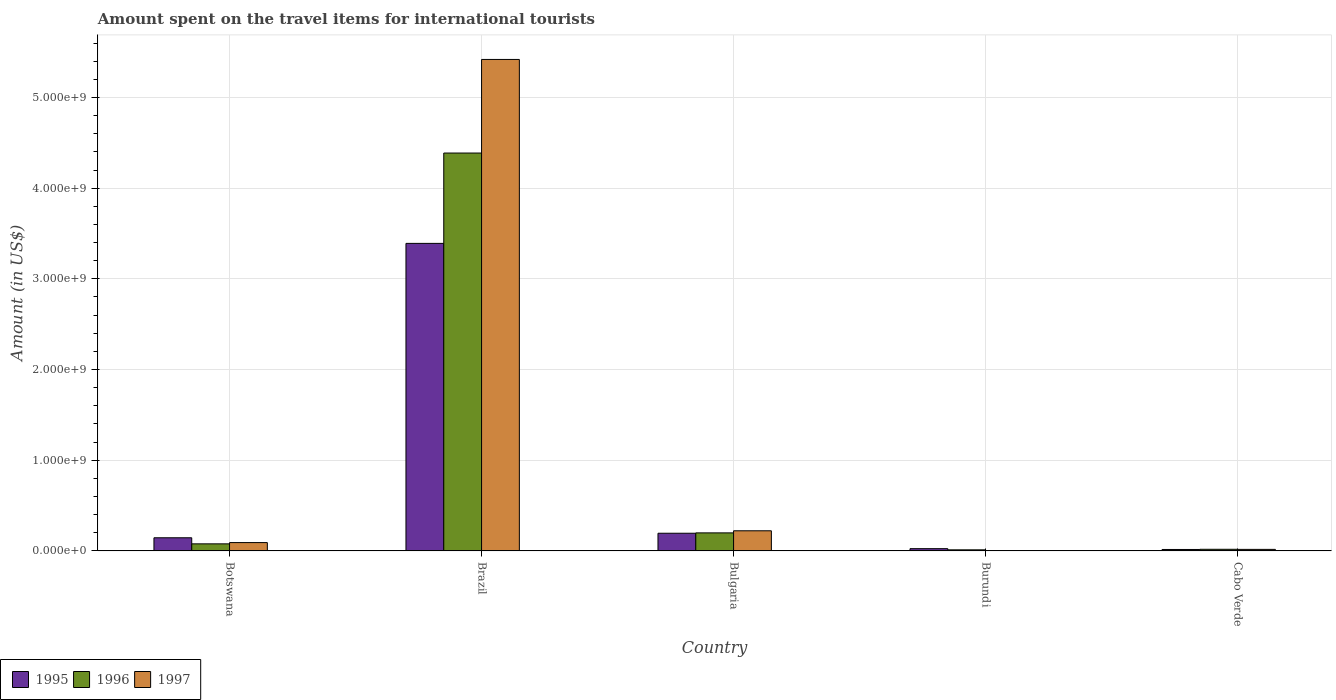How many groups of bars are there?
Your answer should be compact. 5. Are the number of bars per tick equal to the number of legend labels?
Keep it short and to the point. Yes. Are the number of bars on each tick of the X-axis equal?
Keep it short and to the point. Yes. How many bars are there on the 5th tick from the right?
Offer a terse response. 3. What is the label of the 5th group of bars from the left?
Ensure brevity in your answer.  Cabo Verde. In how many cases, is the number of bars for a given country not equal to the number of legend labels?
Provide a short and direct response. 0. What is the amount spent on the travel items for international tourists in 1997 in Burundi?
Offer a terse response. 4.00e+06. Across all countries, what is the maximum amount spent on the travel items for international tourists in 1996?
Offer a very short reply. 4.39e+09. Across all countries, what is the minimum amount spent on the travel items for international tourists in 1995?
Keep it short and to the point. 1.60e+07. In which country was the amount spent on the travel items for international tourists in 1997 maximum?
Keep it short and to the point. Brazil. In which country was the amount spent on the travel items for international tourists in 1995 minimum?
Give a very brief answer. Cabo Verde. What is the total amount spent on the travel items for international tourists in 1996 in the graph?
Your answer should be very brief. 4.69e+09. What is the difference between the amount spent on the travel items for international tourists in 1996 in Brazil and that in Cabo Verde?
Your response must be concise. 4.37e+09. What is the difference between the amount spent on the travel items for international tourists in 1997 in Cabo Verde and the amount spent on the travel items for international tourists in 1996 in Brazil?
Offer a very short reply. -4.37e+09. What is the average amount spent on the travel items for international tourists in 1997 per country?
Your answer should be very brief. 1.15e+09. What is the difference between the amount spent on the travel items for international tourists of/in 1997 and amount spent on the travel items for international tourists of/in 1995 in Brazil?
Your answer should be compact. 2.03e+09. What is the ratio of the amount spent on the travel items for international tourists in 1995 in Brazil to that in Cabo Verde?
Your answer should be compact. 211.94. Is the difference between the amount spent on the travel items for international tourists in 1997 in Burundi and Cabo Verde greater than the difference between the amount spent on the travel items for international tourists in 1995 in Burundi and Cabo Verde?
Keep it short and to the point. No. What is the difference between the highest and the second highest amount spent on the travel items for international tourists in 1997?
Your response must be concise. 5.33e+09. What is the difference between the highest and the lowest amount spent on the travel items for international tourists in 1996?
Give a very brief answer. 4.38e+09. In how many countries, is the amount spent on the travel items for international tourists in 1995 greater than the average amount spent on the travel items for international tourists in 1995 taken over all countries?
Keep it short and to the point. 1. What does the 1st bar from the left in Brazil represents?
Provide a succinct answer. 1995. Is it the case that in every country, the sum of the amount spent on the travel items for international tourists in 1996 and amount spent on the travel items for international tourists in 1995 is greater than the amount spent on the travel items for international tourists in 1997?
Keep it short and to the point. Yes. How many bars are there?
Provide a succinct answer. 15. How many countries are there in the graph?
Make the answer very short. 5. Are the values on the major ticks of Y-axis written in scientific E-notation?
Your response must be concise. Yes. Where does the legend appear in the graph?
Provide a succinct answer. Bottom left. How are the legend labels stacked?
Make the answer very short. Horizontal. What is the title of the graph?
Make the answer very short. Amount spent on the travel items for international tourists. What is the label or title of the Y-axis?
Provide a succinct answer. Amount (in US$). What is the Amount (in US$) of 1995 in Botswana?
Make the answer very short. 1.45e+08. What is the Amount (in US$) in 1996 in Botswana?
Your answer should be very brief. 7.80e+07. What is the Amount (in US$) of 1997 in Botswana?
Make the answer very short. 9.20e+07. What is the Amount (in US$) in 1995 in Brazil?
Make the answer very short. 3.39e+09. What is the Amount (in US$) in 1996 in Brazil?
Make the answer very short. 4.39e+09. What is the Amount (in US$) in 1997 in Brazil?
Ensure brevity in your answer.  5.42e+09. What is the Amount (in US$) of 1995 in Bulgaria?
Your answer should be compact. 1.95e+08. What is the Amount (in US$) of 1996 in Bulgaria?
Give a very brief answer. 1.99e+08. What is the Amount (in US$) in 1997 in Bulgaria?
Ensure brevity in your answer.  2.22e+08. What is the Amount (in US$) of 1995 in Burundi?
Your response must be concise. 2.50e+07. What is the Amount (in US$) in 1995 in Cabo Verde?
Ensure brevity in your answer.  1.60e+07. What is the Amount (in US$) in 1996 in Cabo Verde?
Keep it short and to the point. 1.80e+07. What is the Amount (in US$) in 1997 in Cabo Verde?
Keep it short and to the point. 1.70e+07. Across all countries, what is the maximum Amount (in US$) of 1995?
Your answer should be very brief. 3.39e+09. Across all countries, what is the maximum Amount (in US$) of 1996?
Make the answer very short. 4.39e+09. Across all countries, what is the maximum Amount (in US$) of 1997?
Provide a succinct answer. 5.42e+09. Across all countries, what is the minimum Amount (in US$) in 1995?
Offer a very short reply. 1.60e+07. Across all countries, what is the minimum Amount (in US$) of 1997?
Keep it short and to the point. 4.00e+06. What is the total Amount (in US$) of 1995 in the graph?
Your response must be concise. 3.77e+09. What is the total Amount (in US$) of 1996 in the graph?
Ensure brevity in your answer.  4.69e+09. What is the total Amount (in US$) in 1997 in the graph?
Make the answer very short. 5.75e+09. What is the difference between the Amount (in US$) in 1995 in Botswana and that in Brazil?
Your answer should be compact. -3.25e+09. What is the difference between the Amount (in US$) of 1996 in Botswana and that in Brazil?
Ensure brevity in your answer.  -4.31e+09. What is the difference between the Amount (in US$) in 1997 in Botswana and that in Brazil?
Give a very brief answer. -5.33e+09. What is the difference between the Amount (in US$) of 1995 in Botswana and that in Bulgaria?
Your response must be concise. -5.00e+07. What is the difference between the Amount (in US$) of 1996 in Botswana and that in Bulgaria?
Provide a succinct answer. -1.21e+08. What is the difference between the Amount (in US$) of 1997 in Botswana and that in Bulgaria?
Your response must be concise. -1.30e+08. What is the difference between the Amount (in US$) in 1995 in Botswana and that in Burundi?
Give a very brief answer. 1.20e+08. What is the difference between the Amount (in US$) in 1996 in Botswana and that in Burundi?
Ensure brevity in your answer.  6.60e+07. What is the difference between the Amount (in US$) of 1997 in Botswana and that in Burundi?
Ensure brevity in your answer.  8.80e+07. What is the difference between the Amount (in US$) in 1995 in Botswana and that in Cabo Verde?
Give a very brief answer. 1.29e+08. What is the difference between the Amount (in US$) in 1996 in Botswana and that in Cabo Verde?
Your answer should be very brief. 6.00e+07. What is the difference between the Amount (in US$) in 1997 in Botswana and that in Cabo Verde?
Make the answer very short. 7.50e+07. What is the difference between the Amount (in US$) of 1995 in Brazil and that in Bulgaria?
Your response must be concise. 3.20e+09. What is the difference between the Amount (in US$) of 1996 in Brazil and that in Bulgaria?
Offer a terse response. 4.19e+09. What is the difference between the Amount (in US$) in 1997 in Brazil and that in Bulgaria?
Your answer should be compact. 5.20e+09. What is the difference between the Amount (in US$) of 1995 in Brazil and that in Burundi?
Make the answer very short. 3.37e+09. What is the difference between the Amount (in US$) of 1996 in Brazil and that in Burundi?
Your answer should be compact. 4.38e+09. What is the difference between the Amount (in US$) of 1997 in Brazil and that in Burundi?
Provide a short and direct response. 5.42e+09. What is the difference between the Amount (in US$) in 1995 in Brazil and that in Cabo Verde?
Ensure brevity in your answer.  3.38e+09. What is the difference between the Amount (in US$) of 1996 in Brazil and that in Cabo Verde?
Provide a short and direct response. 4.37e+09. What is the difference between the Amount (in US$) in 1997 in Brazil and that in Cabo Verde?
Offer a very short reply. 5.40e+09. What is the difference between the Amount (in US$) of 1995 in Bulgaria and that in Burundi?
Offer a very short reply. 1.70e+08. What is the difference between the Amount (in US$) of 1996 in Bulgaria and that in Burundi?
Make the answer very short. 1.87e+08. What is the difference between the Amount (in US$) of 1997 in Bulgaria and that in Burundi?
Your answer should be very brief. 2.18e+08. What is the difference between the Amount (in US$) in 1995 in Bulgaria and that in Cabo Verde?
Your response must be concise. 1.79e+08. What is the difference between the Amount (in US$) in 1996 in Bulgaria and that in Cabo Verde?
Make the answer very short. 1.81e+08. What is the difference between the Amount (in US$) in 1997 in Bulgaria and that in Cabo Verde?
Your answer should be very brief. 2.05e+08. What is the difference between the Amount (in US$) in 1995 in Burundi and that in Cabo Verde?
Offer a very short reply. 9.00e+06. What is the difference between the Amount (in US$) of 1996 in Burundi and that in Cabo Verde?
Offer a terse response. -6.00e+06. What is the difference between the Amount (in US$) of 1997 in Burundi and that in Cabo Verde?
Offer a very short reply. -1.30e+07. What is the difference between the Amount (in US$) of 1995 in Botswana and the Amount (in US$) of 1996 in Brazil?
Offer a very short reply. -4.24e+09. What is the difference between the Amount (in US$) of 1995 in Botswana and the Amount (in US$) of 1997 in Brazil?
Keep it short and to the point. -5.27e+09. What is the difference between the Amount (in US$) in 1996 in Botswana and the Amount (in US$) in 1997 in Brazil?
Offer a very short reply. -5.34e+09. What is the difference between the Amount (in US$) in 1995 in Botswana and the Amount (in US$) in 1996 in Bulgaria?
Offer a terse response. -5.40e+07. What is the difference between the Amount (in US$) in 1995 in Botswana and the Amount (in US$) in 1997 in Bulgaria?
Your answer should be very brief. -7.70e+07. What is the difference between the Amount (in US$) of 1996 in Botswana and the Amount (in US$) of 1997 in Bulgaria?
Make the answer very short. -1.44e+08. What is the difference between the Amount (in US$) in 1995 in Botswana and the Amount (in US$) in 1996 in Burundi?
Offer a terse response. 1.33e+08. What is the difference between the Amount (in US$) of 1995 in Botswana and the Amount (in US$) of 1997 in Burundi?
Your answer should be compact. 1.41e+08. What is the difference between the Amount (in US$) of 1996 in Botswana and the Amount (in US$) of 1997 in Burundi?
Give a very brief answer. 7.40e+07. What is the difference between the Amount (in US$) of 1995 in Botswana and the Amount (in US$) of 1996 in Cabo Verde?
Give a very brief answer. 1.27e+08. What is the difference between the Amount (in US$) of 1995 in Botswana and the Amount (in US$) of 1997 in Cabo Verde?
Your answer should be compact. 1.28e+08. What is the difference between the Amount (in US$) of 1996 in Botswana and the Amount (in US$) of 1997 in Cabo Verde?
Offer a very short reply. 6.10e+07. What is the difference between the Amount (in US$) in 1995 in Brazil and the Amount (in US$) in 1996 in Bulgaria?
Your answer should be very brief. 3.19e+09. What is the difference between the Amount (in US$) in 1995 in Brazil and the Amount (in US$) in 1997 in Bulgaria?
Make the answer very short. 3.17e+09. What is the difference between the Amount (in US$) in 1996 in Brazil and the Amount (in US$) in 1997 in Bulgaria?
Your answer should be very brief. 4.16e+09. What is the difference between the Amount (in US$) in 1995 in Brazil and the Amount (in US$) in 1996 in Burundi?
Offer a very short reply. 3.38e+09. What is the difference between the Amount (in US$) in 1995 in Brazil and the Amount (in US$) in 1997 in Burundi?
Ensure brevity in your answer.  3.39e+09. What is the difference between the Amount (in US$) of 1996 in Brazil and the Amount (in US$) of 1997 in Burundi?
Provide a succinct answer. 4.38e+09. What is the difference between the Amount (in US$) in 1995 in Brazil and the Amount (in US$) in 1996 in Cabo Verde?
Your answer should be compact. 3.37e+09. What is the difference between the Amount (in US$) of 1995 in Brazil and the Amount (in US$) of 1997 in Cabo Verde?
Provide a short and direct response. 3.37e+09. What is the difference between the Amount (in US$) of 1996 in Brazil and the Amount (in US$) of 1997 in Cabo Verde?
Make the answer very short. 4.37e+09. What is the difference between the Amount (in US$) of 1995 in Bulgaria and the Amount (in US$) of 1996 in Burundi?
Provide a succinct answer. 1.83e+08. What is the difference between the Amount (in US$) of 1995 in Bulgaria and the Amount (in US$) of 1997 in Burundi?
Your response must be concise. 1.91e+08. What is the difference between the Amount (in US$) in 1996 in Bulgaria and the Amount (in US$) in 1997 in Burundi?
Offer a very short reply. 1.95e+08. What is the difference between the Amount (in US$) in 1995 in Bulgaria and the Amount (in US$) in 1996 in Cabo Verde?
Your answer should be compact. 1.77e+08. What is the difference between the Amount (in US$) in 1995 in Bulgaria and the Amount (in US$) in 1997 in Cabo Verde?
Ensure brevity in your answer.  1.78e+08. What is the difference between the Amount (in US$) in 1996 in Bulgaria and the Amount (in US$) in 1997 in Cabo Verde?
Your answer should be compact. 1.82e+08. What is the difference between the Amount (in US$) of 1996 in Burundi and the Amount (in US$) of 1997 in Cabo Verde?
Provide a succinct answer. -5.00e+06. What is the average Amount (in US$) of 1995 per country?
Provide a short and direct response. 7.54e+08. What is the average Amount (in US$) in 1996 per country?
Give a very brief answer. 9.39e+08. What is the average Amount (in US$) of 1997 per country?
Make the answer very short. 1.15e+09. What is the difference between the Amount (in US$) in 1995 and Amount (in US$) in 1996 in Botswana?
Provide a short and direct response. 6.70e+07. What is the difference between the Amount (in US$) in 1995 and Amount (in US$) in 1997 in Botswana?
Provide a short and direct response. 5.30e+07. What is the difference between the Amount (in US$) in 1996 and Amount (in US$) in 1997 in Botswana?
Your response must be concise. -1.40e+07. What is the difference between the Amount (in US$) in 1995 and Amount (in US$) in 1996 in Brazil?
Provide a succinct answer. -9.96e+08. What is the difference between the Amount (in US$) in 1995 and Amount (in US$) in 1997 in Brazil?
Your response must be concise. -2.03e+09. What is the difference between the Amount (in US$) of 1996 and Amount (in US$) of 1997 in Brazil?
Your answer should be compact. -1.03e+09. What is the difference between the Amount (in US$) of 1995 and Amount (in US$) of 1996 in Bulgaria?
Provide a short and direct response. -4.00e+06. What is the difference between the Amount (in US$) of 1995 and Amount (in US$) of 1997 in Bulgaria?
Your response must be concise. -2.70e+07. What is the difference between the Amount (in US$) in 1996 and Amount (in US$) in 1997 in Bulgaria?
Offer a very short reply. -2.30e+07. What is the difference between the Amount (in US$) of 1995 and Amount (in US$) of 1996 in Burundi?
Your answer should be very brief. 1.30e+07. What is the difference between the Amount (in US$) in 1995 and Amount (in US$) in 1997 in Burundi?
Ensure brevity in your answer.  2.10e+07. What is the difference between the Amount (in US$) of 1996 and Amount (in US$) of 1997 in Cabo Verde?
Your answer should be compact. 1.00e+06. What is the ratio of the Amount (in US$) of 1995 in Botswana to that in Brazil?
Your answer should be compact. 0.04. What is the ratio of the Amount (in US$) of 1996 in Botswana to that in Brazil?
Keep it short and to the point. 0.02. What is the ratio of the Amount (in US$) of 1997 in Botswana to that in Brazil?
Your response must be concise. 0.02. What is the ratio of the Amount (in US$) of 1995 in Botswana to that in Bulgaria?
Your answer should be compact. 0.74. What is the ratio of the Amount (in US$) in 1996 in Botswana to that in Bulgaria?
Make the answer very short. 0.39. What is the ratio of the Amount (in US$) in 1997 in Botswana to that in Bulgaria?
Provide a short and direct response. 0.41. What is the ratio of the Amount (in US$) of 1996 in Botswana to that in Burundi?
Offer a terse response. 6.5. What is the ratio of the Amount (in US$) of 1997 in Botswana to that in Burundi?
Provide a short and direct response. 23. What is the ratio of the Amount (in US$) in 1995 in Botswana to that in Cabo Verde?
Provide a succinct answer. 9.06. What is the ratio of the Amount (in US$) in 1996 in Botswana to that in Cabo Verde?
Your answer should be very brief. 4.33. What is the ratio of the Amount (in US$) in 1997 in Botswana to that in Cabo Verde?
Give a very brief answer. 5.41. What is the ratio of the Amount (in US$) of 1995 in Brazil to that in Bulgaria?
Your answer should be compact. 17.39. What is the ratio of the Amount (in US$) in 1996 in Brazil to that in Bulgaria?
Provide a succinct answer. 22.05. What is the ratio of the Amount (in US$) of 1997 in Brazil to that in Bulgaria?
Provide a succinct answer. 24.41. What is the ratio of the Amount (in US$) of 1995 in Brazil to that in Burundi?
Provide a succinct answer. 135.64. What is the ratio of the Amount (in US$) in 1996 in Brazil to that in Burundi?
Ensure brevity in your answer.  365.58. What is the ratio of the Amount (in US$) of 1997 in Brazil to that in Burundi?
Your response must be concise. 1354.75. What is the ratio of the Amount (in US$) of 1995 in Brazil to that in Cabo Verde?
Your answer should be compact. 211.94. What is the ratio of the Amount (in US$) of 1996 in Brazil to that in Cabo Verde?
Offer a terse response. 243.72. What is the ratio of the Amount (in US$) in 1997 in Brazil to that in Cabo Verde?
Your answer should be compact. 318.76. What is the ratio of the Amount (in US$) of 1996 in Bulgaria to that in Burundi?
Provide a short and direct response. 16.58. What is the ratio of the Amount (in US$) in 1997 in Bulgaria to that in Burundi?
Your response must be concise. 55.5. What is the ratio of the Amount (in US$) of 1995 in Bulgaria to that in Cabo Verde?
Give a very brief answer. 12.19. What is the ratio of the Amount (in US$) in 1996 in Bulgaria to that in Cabo Verde?
Give a very brief answer. 11.06. What is the ratio of the Amount (in US$) of 1997 in Bulgaria to that in Cabo Verde?
Provide a short and direct response. 13.06. What is the ratio of the Amount (in US$) of 1995 in Burundi to that in Cabo Verde?
Offer a very short reply. 1.56. What is the ratio of the Amount (in US$) of 1996 in Burundi to that in Cabo Verde?
Provide a short and direct response. 0.67. What is the ratio of the Amount (in US$) of 1997 in Burundi to that in Cabo Verde?
Provide a succinct answer. 0.24. What is the difference between the highest and the second highest Amount (in US$) in 1995?
Offer a very short reply. 3.20e+09. What is the difference between the highest and the second highest Amount (in US$) of 1996?
Keep it short and to the point. 4.19e+09. What is the difference between the highest and the second highest Amount (in US$) of 1997?
Keep it short and to the point. 5.20e+09. What is the difference between the highest and the lowest Amount (in US$) of 1995?
Provide a short and direct response. 3.38e+09. What is the difference between the highest and the lowest Amount (in US$) of 1996?
Your response must be concise. 4.38e+09. What is the difference between the highest and the lowest Amount (in US$) in 1997?
Provide a short and direct response. 5.42e+09. 